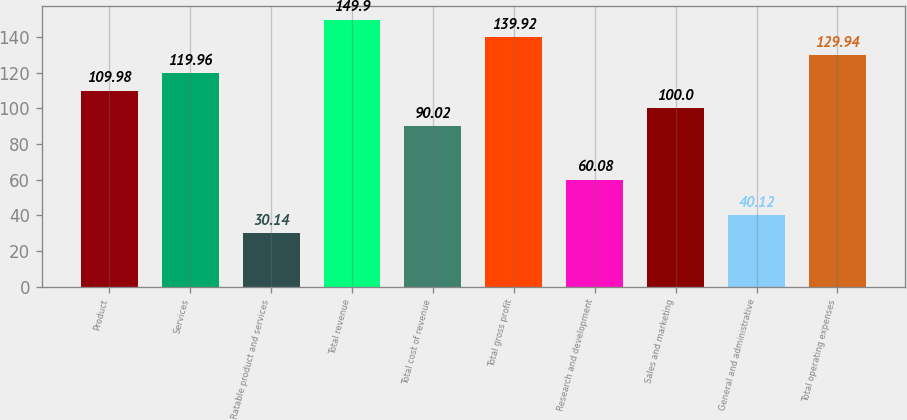Convert chart. <chart><loc_0><loc_0><loc_500><loc_500><bar_chart><fcel>Product<fcel>Services<fcel>Ratable product and services<fcel>Total revenue<fcel>Total cost of revenue<fcel>Total gross profit<fcel>Research and development<fcel>Sales and marketing<fcel>General and administrative<fcel>Total operating expenses<nl><fcel>109.98<fcel>119.96<fcel>30.14<fcel>149.9<fcel>90.02<fcel>139.92<fcel>60.08<fcel>100<fcel>40.12<fcel>129.94<nl></chart> 